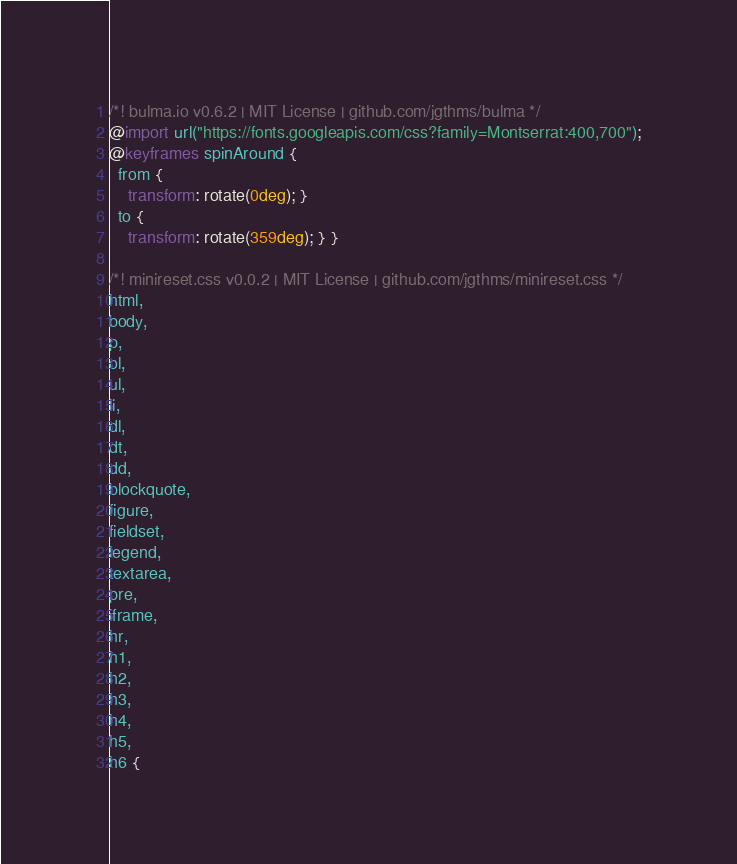<code> <loc_0><loc_0><loc_500><loc_500><_CSS_>/*! bulma.io v0.6.2 | MIT License | github.com/jgthms/bulma */
@import url("https://fonts.googleapis.com/css?family=Montserrat:400,700");
@keyframes spinAround {
  from {
    transform: rotate(0deg); }
  to {
    transform: rotate(359deg); } }

/*! minireset.css v0.0.2 | MIT License | github.com/jgthms/minireset.css */
html,
body,
p,
ol,
ul,
li,
dl,
dt,
dd,
blockquote,
figure,
fieldset,
legend,
textarea,
pre,
iframe,
hr,
h1,
h2,
h3,
h4,
h5,
h6 {</code> 